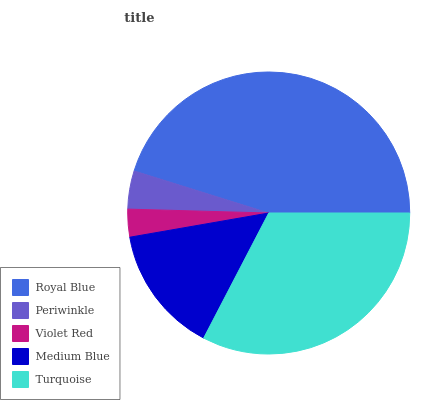Is Violet Red the minimum?
Answer yes or no. Yes. Is Royal Blue the maximum?
Answer yes or no. Yes. Is Periwinkle the minimum?
Answer yes or no. No. Is Periwinkle the maximum?
Answer yes or no. No. Is Royal Blue greater than Periwinkle?
Answer yes or no. Yes. Is Periwinkle less than Royal Blue?
Answer yes or no. Yes. Is Periwinkle greater than Royal Blue?
Answer yes or no. No. Is Royal Blue less than Periwinkle?
Answer yes or no. No. Is Medium Blue the high median?
Answer yes or no. Yes. Is Medium Blue the low median?
Answer yes or no. Yes. Is Periwinkle the high median?
Answer yes or no. No. Is Periwinkle the low median?
Answer yes or no. No. 